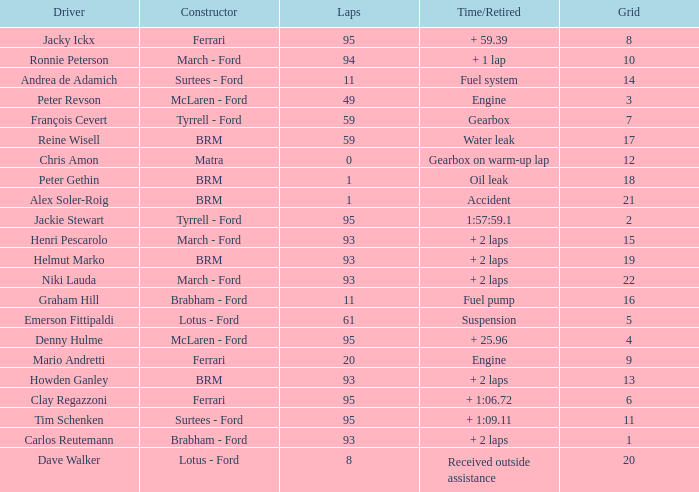What is the lowest grid with matra as constructor? 12.0. 